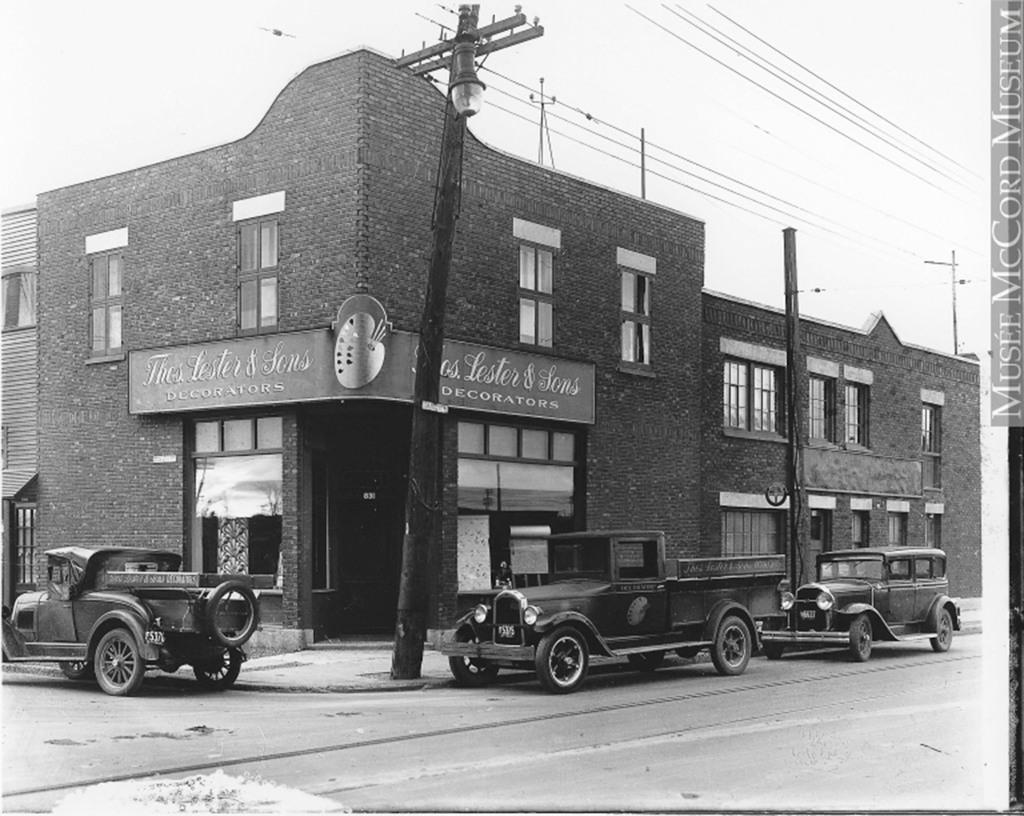Describe this image in one or two sentences. In the picture we can see an old building with a shop to it and a name of the shop is Lester and sons decorators and under it we can see windows and door and on the top of the shop also we can see some windows and beside it also we can see a building with windows and near the building we can see three vintage cars are parked near the path and we can see two poles with wires to it and in the background we can see sky. 